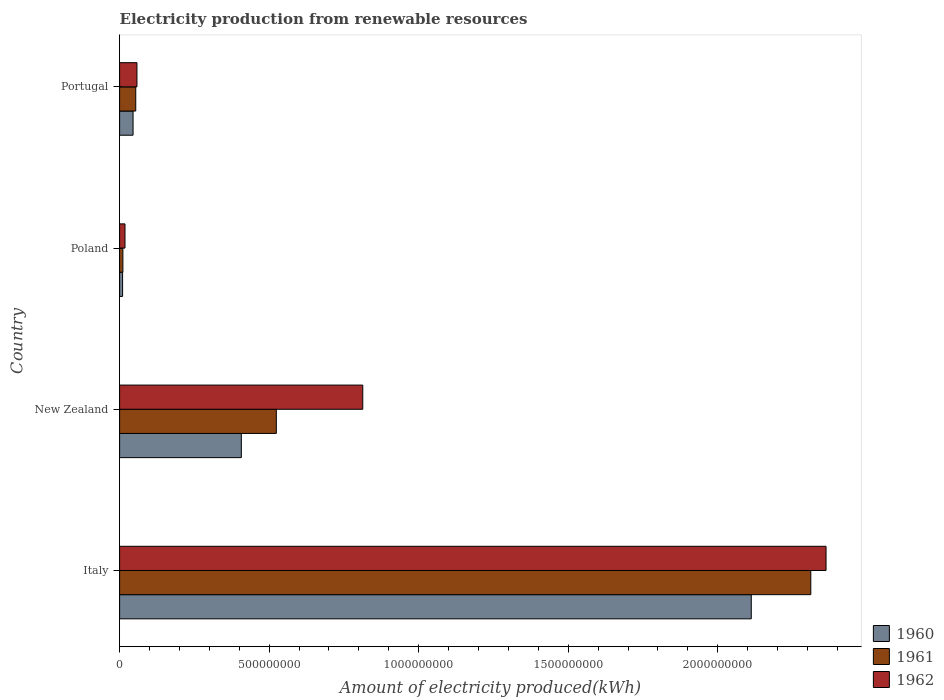How many different coloured bars are there?
Offer a terse response. 3. How many groups of bars are there?
Provide a short and direct response. 4. Are the number of bars on each tick of the Y-axis equal?
Your answer should be compact. Yes. How many bars are there on the 3rd tick from the top?
Give a very brief answer. 3. What is the label of the 3rd group of bars from the top?
Your response must be concise. New Zealand. What is the amount of electricity produced in 1960 in New Zealand?
Keep it short and to the point. 4.07e+08. Across all countries, what is the maximum amount of electricity produced in 1960?
Your response must be concise. 2.11e+09. Across all countries, what is the minimum amount of electricity produced in 1960?
Make the answer very short. 1.00e+07. In which country was the amount of electricity produced in 1962 maximum?
Your answer should be compact. Italy. What is the total amount of electricity produced in 1960 in the graph?
Provide a succinct answer. 2.57e+09. What is the difference between the amount of electricity produced in 1961 in New Zealand and that in Portugal?
Keep it short and to the point. 4.70e+08. What is the difference between the amount of electricity produced in 1962 in Poland and the amount of electricity produced in 1961 in Portugal?
Your answer should be very brief. -3.60e+07. What is the average amount of electricity produced in 1960 per country?
Provide a short and direct response. 6.44e+08. What is the difference between the amount of electricity produced in 1960 and amount of electricity produced in 1961 in New Zealand?
Make the answer very short. -1.17e+08. What is the ratio of the amount of electricity produced in 1960 in New Zealand to that in Poland?
Make the answer very short. 40.7. Is the difference between the amount of electricity produced in 1960 in Italy and Poland greater than the difference between the amount of electricity produced in 1961 in Italy and Poland?
Offer a very short reply. No. What is the difference between the highest and the second highest amount of electricity produced in 1961?
Keep it short and to the point. 1.79e+09. What is the difference between the highest and the lowest amount of electricity produced in 1960?
Your response must be concise. 2.10e+09. Is it the case that in every country, the sum of the amount of electricity produced in 1960 and amount of electricity produced in 1962 is greater than the amount of electricity produced in 1961?
Ensure brevity in your answer.  Yes. How many bars are there?
Offer a terse response. 12. How many countries are there in the graph?
Your answer should be very brief. 4. Are the values on the major ticks of X-axis written in scientific E-notation?
Offer a terse response. No. Does the graph contain any zero values?
Offer a terse response. No. Does the graph contain grids?
Make the answer very short. No. Where does the legend appear in the graph?
Your response must be concise. Bottom right. How many legend labels are there?
Ensure brevity in your answer.  3. How are the legend labels stacked?
Offer a very short reply. Vertical. What is the title of the graph?
Your answer should be very brief. Electricity production from renewable resources. Does "1968" appear as one of the legend labels in the graph?
Your answer should be very brief. No. What is the label or title of the X-axis?
Ensure brevity in your answer.  Amount of electricity produced(kWh). What is the label or title of the Y-axis?
Make the answer very short. Country. What is the Amount of electricity produced(kWh) of 1960 in Italy?
Provide a succinct answer. 2.11e+09. What is the Amount of electricity produced(kWh) of 1961 in Italy?
Your answer should be very brief. 2.31e+09. What is the Amount of electricity produced(kWh) of 1962 in Italy?
Your answer should be very brief. 2.36e+09. What is the Amount of electricity produced(kWh) of 1960 in New Zealand?
Make the answer very short. 4.07e+08. What is the Amount of electricity produced(kWh) in 1961 in New Zealand?
Ensure brevity in your answer.  5.24e+08. What is the Amount of electricity produced(kWh) of 1962 in New Zealand?
Your answer should be compact. 8.13e+08. What is the Amount of electricity produced(kWh) of 1960 in Poland?
Make the answer very short. 1.00e+07. What is the Amount of electricity produced(kWh) of 1961 in Poland?
Ensure brevity in your answer.  1.10e+07. What is the Amount of electricity produced(kWh) in 1962 in Poland?
Give a very brief answer. 1.80e+07. What is the Amount of electricity produced(kWh) of 1960 in Portugal?
Your answer should be very brief. 4.50e+07. What is the Amount of electricity produced(kWh) of 1961 in Portugal?
Provide a short and direct response. 5.40e+07. What is the Amount of electricity produced(kWh) in 1962 in Portugal?
Provide a short and direct response. 5.80e+07. Across all countries, what is the maximum Amount of electricity produced(kWh) of 1960?
Your answer should be very brief. 2.11e+09. Across all countries, what is the maximum Amount of electricity produced(kWh) in 1961?
Make the answer very short. 2.31e+09. Across all countries, what is the maximum Amount of electricity produced(kWh) of 1962?
Keep it short and to the point. 2.36e+09. Across all countries, what is the minimum Amount of electricity produced(kWh) in 1960?
Ensure brevity in your answer.  1.00e+07. Across all countries, what is the minimum Amount of electricity produced(kWh) in 1961?
Provide a succinct answer. 1.10e+07. Across all countries, what is the minimum Amount of electricity produced(kWh) in 1962?
Keep it short and to the point. 1.80e+07. What is the total Amount of electricity produced(kWh) in 1960 in the graph?
Make the answer very short. 2.57e+09. What is the total Amount of electricity produced(kWh) in 1961 in the graph?
Offer a very short reply. 2.90e+09. What is the total Amount of electricity produced(kWh) in 1962 in the graph?
Ensure brevity in your answer.  3.25e+09. What is the difference between the Amount of electricity produced(kWh) of 1960 in Italy and that in New Zealand?
Offer a terse response. 1.70e+09. What is the difference between the Amount of electricity produced(kWh) in 1961 in Italy and that in New Zealand?
Offer a terse response. 1.79e+09. What is the difference between the Amount of electricity produced(kWh) in 1962 in Italy and that in New Zealand?
Your response must be concise. 1.55e+09. What is the difference between the Amount of electricity produced(kWh) in 1960 in Italy and that in Poland?
Offer a very short reply. 2.10e+09. What is the difference between the Amount of electricity produced(kWh) of 1961 in Italy and that in Poland?
Your answer should be very brief. 2.30e+09. What is the difference between the Amount of electricity produced(kWh) in 1962 in Italy and that in Poland?
Make the answer very short. 2.34e+09. What is the difference between the Amount of electricity produced(kWh) of 1960 in Italy and that in Portugal?
Ensure brevity in your answer.  2.07e+09. What is the difference between the Amount of electricity produced(kWh) of 1961 in Italy and that in Portugal?
Your response must be concise. 2.26e+09. What is the difference between the Amount of electricity produced(kWh) in 1962 in Italy and that in Portugal?
Provide a succinct answer. 2.30e+09. What is the difference between the Amount of electricity produced(kWh) of 1960 in New Zealand and that in Poland?
Your answer should be compact. 3.97e+08. What is the difference between the Amount of electricity produced(kWh) in 1961 in New Zealand and that in Poland?
Offer a terse response. 5.13e+08. What is the difference between the Amount of electricity produced(kWh) in 1962 in New Zealand and that in Poland?
Offer a terse response. 7.95e+08. What is the difference between the Amount of electricity produced(kWh) of 1960 in New Zealand and that in Portugal?
Provide a succinct answer. 3.62e+08. What is the difference between the Amount of electricity produced(kWh) of 1961 in New Zealand and that in Portugal?
Make the answer very short. 4.70e+08. What is the difference between the Amount of electricity produced(kWh) of 1962 in New Zealand and that in Portugal?
Give a very brief answer. 7.55e+08. What is the difference between the Amount of electricity produced(kWh) of 1960 in Poland and that in Portugal?
Ensure brevity in your answer.  -3.50e+07. What is the difference between the Amount of electricity produced(kWh) in 1961 in Poland and that in Portugal?
Your answer should be compact. -4.30e+07. What is the difference between the Amount of electricity produced(kWh) in 1962 in Poland and that in Portugal?
Your answer should be compact. -4.00e+07. What is the difference between the Amount of electricity produced(kWh) of 1960 in Italy and the Amount of electricity produced(kWh) of 1961 in New Zealand?
Provide a succinct answer. 1.59e+09. What is the difference between the Amount of electricity produced(kWh) of 1960 in Italy and the Amount of electricity produced(kWh) of 1962 in New Zealand?
Give a very brief answer. 1.30e+09. What is the difference between the Amount of electricity produced(kWh) of 1961 in Italy and the Amount of electricity produced(kWh) of 1962 in New Zealand?
Offer a terse response. 1.50e+09. What is the difference between the Amount of electricity produced(kWh) in 1960 in Italy and the Amount of electricity produced(kWh) in 1961 in Poland?
Provide a succinct answer. 2.10e+09. What is the difference between the Amount of electricity produced(kWh) in 1960 in Italy and the Amount of electricity produced(kWh) in 1962 in Poland?
Make the answer very short. 2.09e+09. What is the difference between the Amount of electricity produced(kWh) of 1961 in Italy and the Amount of electricity produced(kWh) of 1962 in Poland?
Provide a succinct answer. 2.29e+09. What is the difference between the Amount of electricity produced(kWh) of 1960 in Italy and the Amount of electricity produced(kWh) of 1961 in Portugal?
Provide a short and direct response. 2.06e+09. What is the difference between the Amount of electricity produced(kWh) of 1960 in Italy and the Amount of electricity produced(kWh) of 1962 in Portugal?
Provide a short and direct response. 2.05e+09. What is the difference between the Amount of electricity produced(kWh) in 1961 in Italy and the Amount of electricity produced(kWh) in 1962 in Portugal?
Make the answer very short. 2.25e+09. What is the difference between the Amount of electricity produced(kWh) in 1960 in New Zealand and the Amount of electricity produced(kWh) in 1961 in Poland?
Ensure brevity in your answer.  3.96e+08. What is the difference between the Amount of electricity produced(kWh) of 1960 in New Zealand and the Amount of electricity produced(kWh) of 1962 in Poland?
Your response must be concise. 3.89e+08. What is the difference between the Amount of electricity produced(kWh) of 1961 in New Zealand and the Amount of electricity produced(kWh) of 1962 in Poland?
Your response must be concise. 5.06e+08. What is the difference between the Amount of electricity produced(kWh) in 1960 in New Zealand and the Amount of electricity produced(kWh) in 1961 in Portugal?
Ensure brevity in your answer.  3.53e+08. What is the difference between the Amount of electricity produced(kWh) of 1960 in New Zealand and the Amount of electricity produced(kWh) of 1962 in Portugal?
Offer a terse response. 3.49e+08. What is the difference between the Amount of electricity produced(kWh) of 1961 in New Zealand and the Amount of electricity produced(kWh) of 1962 in Portugal?
Keep it short and to the point. 4.66e+08. What is the difference between the Amount of electricity produced(kWh) of 1960 in Poland and the Amount of electricity produced(kWh) of 1961 in Portugal?
Give a very brief answer. -4.40e+07. What is the difference between the Amount of electricity produced(kWh) of 1960 in Poland and the Amount of electricity produced(kWh) of 1962 in Portugal?
Your answer should be compact. -4.80e+07. What is the difference between the Amount of electricity produced(kWh) in 1961 in Poland and the Amount of electricity produced(kWh) in 1962 in Portugal?
Provide a succinct answer. -4.70e+07. What is the average Amount of electricity produced(kWh) in 1960 per country?
Provide a short and direct response. 6.44e+08. What is the average Amount of electricity produced(kWh) of 1961 per country?
Provide a short and direct response. 7.25e+08. What is the average Amount of electricity produced(kWh) of 1962 per country?
Offer a very short reply. 8.13e+08. What is the difference between the Amount of electricity produced(kWh) in 1960 and Amount of electricity produced(kWh) in 1961 in Italy?
Offer a very short reply. -1.99e+08. What is the difference between the Amount of electricity produced(kWh) of 1960 and Amount of electricity produced(kWh) of 1962 in Italy?
Your answer should be compact. -2.50e+08. What is the difference between the Amount of electricity produced(kWh) of 1961 and Amount of electricity produced(kWh) of 1962 in Italy?
Your response must be concise. -5.10e+07. What is the difference between the Amount of electricity produced(kWh) of 1960 and Amount of electricity produced(kWh) of 1961 in New Zealand?
Your answer should be very brief. -1.17e+08. What is the difference between the Amount of electricity produced(kWh) in 1960 and Amount of electricity produced(kWh) in 1962 in New Zealand?
Provide a succinct answer. -4.06e+08. What is the difference between the Amount of electricity produced(kWh) in 1961 and Amount of electricity produced(kWh) in 1962 in New Zealand?
Your answer should be very brief. -2.89e+08. What is the difference between the Amount of electricity produced(kWh) of 1960 and Amount of electricity produced(kWh) of 1962 in Poland?
Your answer should be very brief. -8.00e+06. What is the difference between the Amount of electricity produced(kWh) of 1961 and Amount of electricity produced(kWh) of 1962 in Poland?
Provide a short and direct response. -7.00e+06. What is the difference between the Amount of electricity produced(kWh) of 1960 and Amount of electricity produced(kWh) of 1961 in Portugal?
Keep it short and to the point. -9.00e+06. What is the difference between the Amount of electricity produced(kWh) in 1960 and Amount of electricity produced(kWh) in 1962 in Portugal?
Ensure brevity in your answer.  -1.30e+07. What is the ratio of the Amount of electricity produced(kWh) of 1960 in Italy to that in New Zealand?
Your answer should be compact. 5.19. What is the ratio of the Amount of electricity produced(kWh) in 1961 in Italy to that in New Zealand?
Your answer should be very brief. 4.41. What is the ratio of the Amount of electricity produced(kWh) in 1962 in Italy to that in New Zealand?
Provide a short and direct response. 2.91. What is the ratio of the Amount of electricity produced(kWh) of 1960 in Italy to that in Poland?
Your answer should be compact. 211.2. What is the ratio of the Amount of electricity produced(kWh) in 1961 in Italy to that in Poland?
Ensure brevity in your answer.  210.09. What is the ratio of the Amount of electricity produced(kWh) of 1962 in Italy to that in Poland?
Offer a very short reply. 131.22. What is the ratio of the Amount of electricity produced(kWh) in 1960 in Italy to that in Portugal?
Your answer should be compact. 46.93. What is the ratio of the Amount of electricity produced(kWh) in 1961 in Italy to that in Portugal?
Your answer should be very brief. 42.8. What is the ratio of the Amount of electricity produced(kWh) in 1962 in Italy to that in Portugal?
Your answer should be compact. 40.72. What is the ratio of the Amount of electricity produced(kWh) in 1960 in New Zealand to that in Poland?
Ensure brevity in your answer.  40.7. What is the ratio of the Amount of electricity produced(kWh) of 1961 in New Zealand to that in Poland?
Make the answer very short. 47.64. What is the ratio of the Amount of electricity produced(kWh) of 1962 in New Zealand to that in Poland?
Ensure brevity in your answer.  45.17. What is the ratio of the Amount of electricity produced(kWh) in 1960 in New Zealand to that in Portugal?
Provide a short and direct response. 9.04. What is the ratio of the Amount of electricity produced(kWh) of 1961 in New Zealand to that in Portugal?
Provide a short and direct response. 9.7. What is the ratio of the Amount of electricity produced(kWh) in 1962 in New Zealand to that in Portugal?
Give a very brief answer. 14.02. What is the ratio of the Amount of electricity produced(kWh) of 1960 in Poland to that in Portugal?
Your response must be concise. 0.22. What is the ratio of the Amount of electricity produced(kWh) in 1961 in Poland to that in Portugal?
Make the answer very short. 0.2. What is the ratio of the Amount of electricity produced(kWh) of 1962 in Poland to that in Portugal?
Provide a succinct answer. 0.31. What is the difference between the highest and the second highest Amount of electricity produced(kWh) in 1960?
Offer a terse response. 1.70e+09. What is the difference between the highest and the second highest Amount of electricity produced(kWh) in 1961?
Your response must be concise. 1.79e+09. What is the difference between the highest and the second highest Amount of electricity produced(kWh) of 1962?
Ensure brevity in your answer.  1.55e+09. What is the difference between the highest and the lowest Amount of electricity produced(kWh) of 1960?
Your answer should be very brief. 2.10e+09. What is the difference between the highest and the lowest Amount of electricity produced(kWh) of 1961?
Keep it short and to the point. 2.30e+09. What is the difference between the highest and the lowest Amount of electricity produced(kWh) of 1962?
Ensure brevity in your answer.  2.34e+09. 